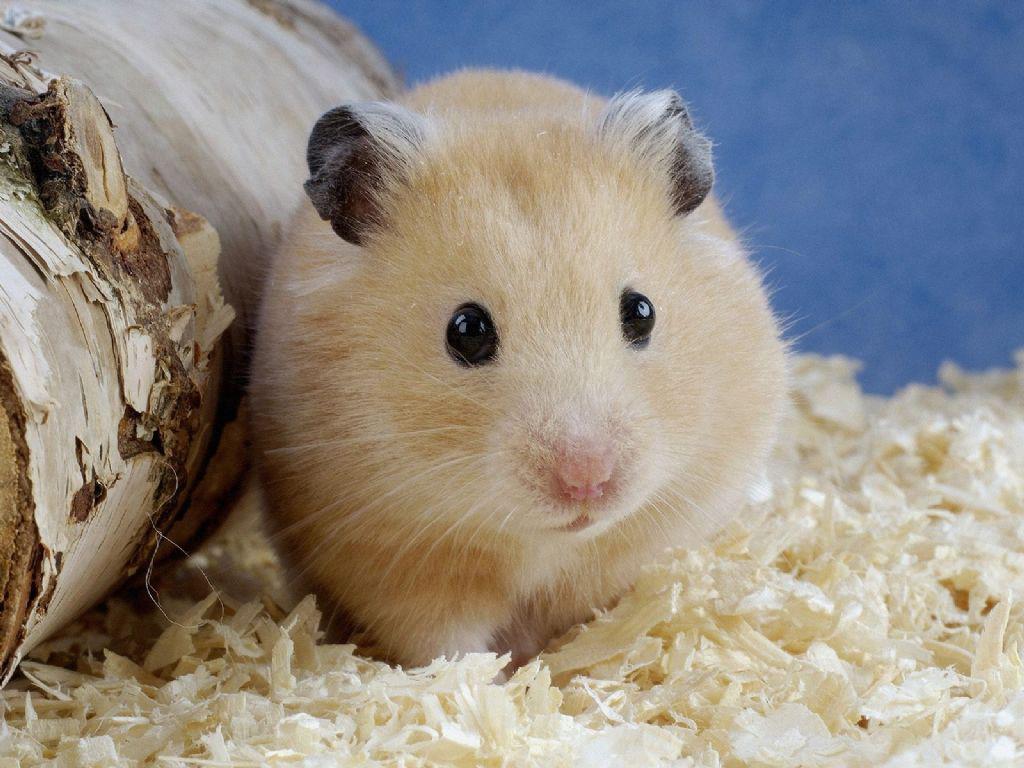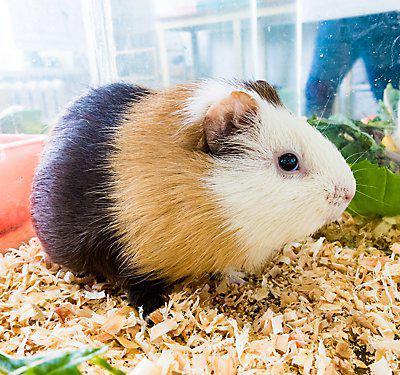The first image is the image on the left, the second image is the image on the right. For the images shown, is this caption "One hamster is tri-colored." true? Answer yes or no. Yes. 